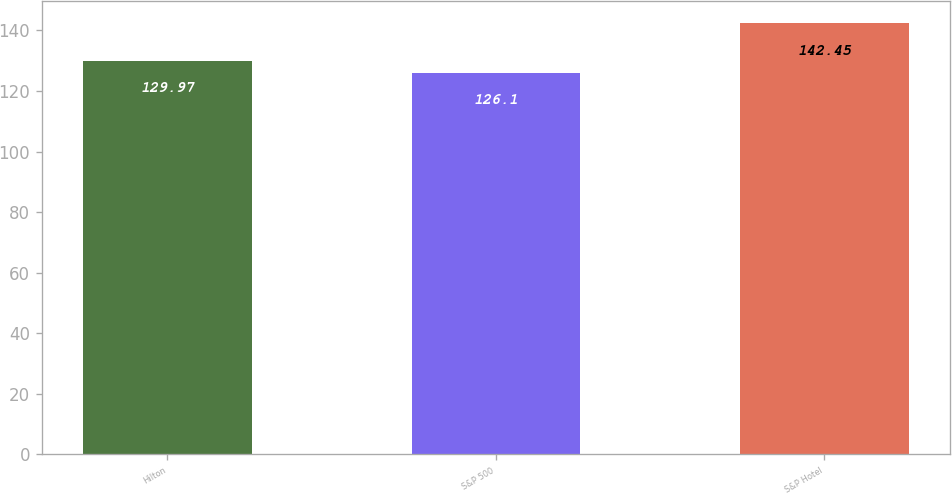<chart> <loc_0><loc_0><loc_500><loc_500><bar_chart><fcel>Hilton<fcel>S&P 500<fcel>S&P Hotel<nl><fcel>129.97<fcel>126.1<fcel>142.45<nl></chart> 